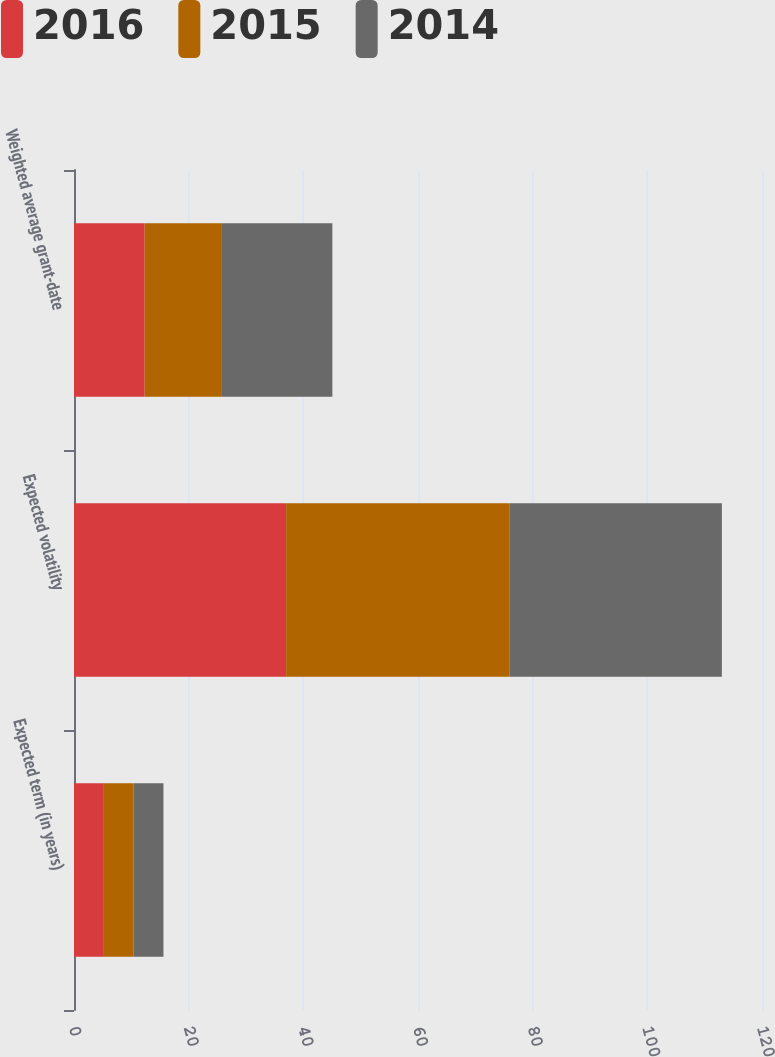<chart> <loc_0><loc_0><loc_500><loc_500><stacked_bar_chart><ecel><fcel>Expected term (in years)<fcel>Expected volatility<fcel>Weighted average grant-date<nl><fcel>2016<fcel>5.21<fcel>37<fcel>12.33<nl><fcel>2015<fcel>5.16<fcel>39<fcel>13.47<nl><fcel>2014<fcel>5.23<fcel>37<fcel>19.26<nl></chart> 